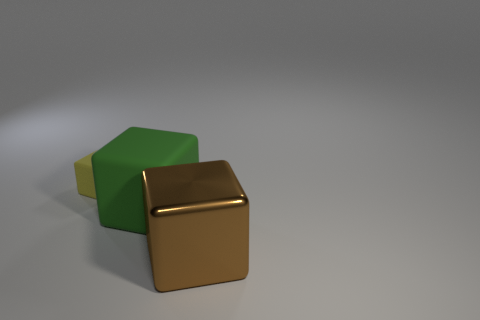Is there any other thing that is the same size as the yellow matte block?
Your response must be concise. No. What material is the big brown cube?
Provide a short and direct response. Metal. There is a thing that is on the left side of the metal block and in front of the yellow block; how big is it?
Provide a short and direct response. Large. There is a matte object on the right side of the matte object left of the large cube behind the metal object; what size is it?
Give a very brief answer. Large. What is the size of the brown metal thing?
Offer a terse response. Large. Is there anything else that is made of the same material as the brown block?
Provide a short and direct response. No. There is a big object on the right side of the matte cube that is on the right side of the tiny object; is there a large metallic cube that is in front of it?
Keep it short and to the point. No. What number of small things are either shiny objects or green rubber blocks?
Give a very brief answer. 0. Is there any other thing that has the same color as the metallic thing?
Your answer should be very brief. No. Do the object that is in front of the green object and the green cube have the same size?
Give a very brief answer. Yes. 